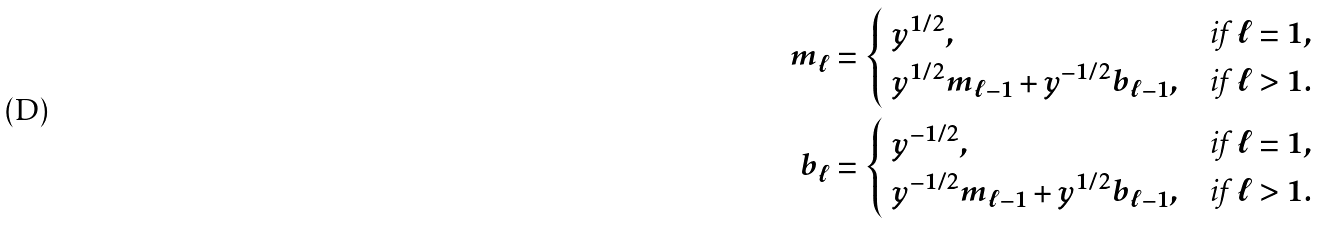<formula> <loc_0><loc_0><loc_500><loc_500>m _ { \ell } & = \begin{cases} \ y ^ { 1 / 2 } , & \text {if } \ell = 1 , \\ \ y ^ { 1 / 2 } m _ { \ell - 1 } + y ^ { - 1 / 2 } b _ { \ell - 1 } , & \text {if } \ell > 1 . \end{cases} \\ b _ { \ell } & = \begin{cases} \ y ^ { - 1 / 2 } , & \text {if } \ell = 1 , \\ \ y ^ { - 1 / 2 } m _ { \ell - 1 } + y ^ { 1 / 2 } b _ { \ell - 1 } , & \text {if } \ell > 1 . \end{cases}</formula> 